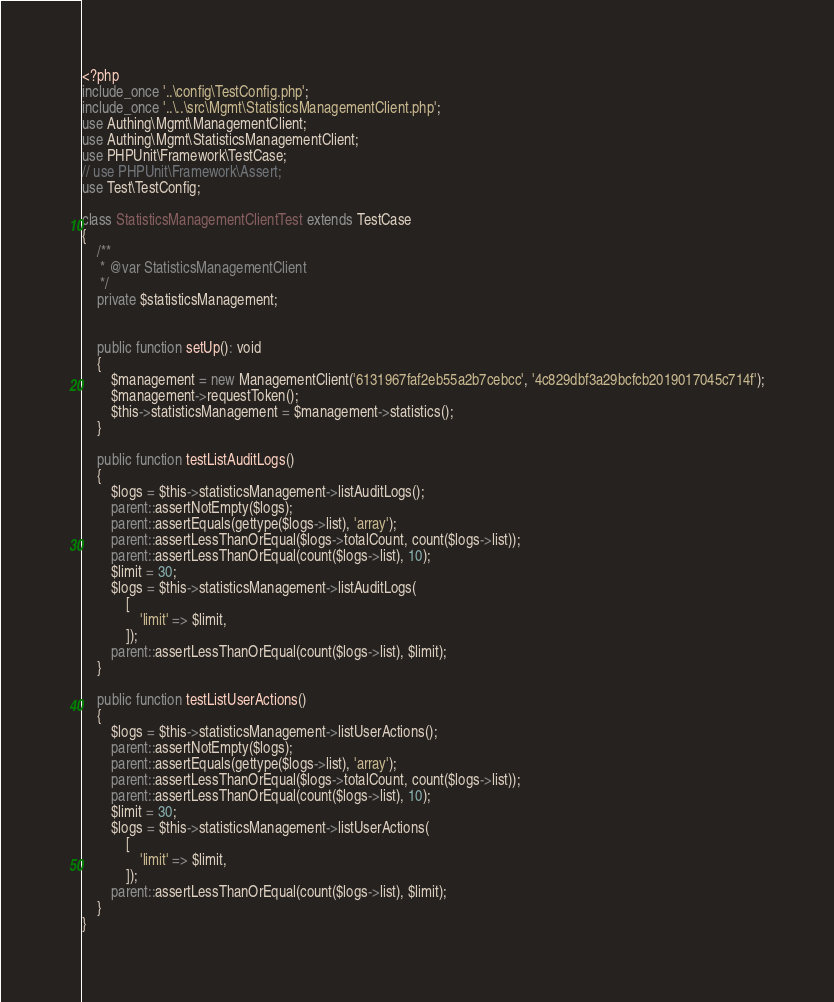Convert code to text. <code><loc_0><loc_0><loc_500><loc_500><_PHP_><?php
include_once '..\config\TestConfig.php';
include_once '..\..\src\Mgmt\StatisticsManagementClient.php';
use Authing\Mgmt\ManagementClient;
use Authing\Mgmt\StatisticsManagementClient;
use PHPUnit\Framework\TestCase;
// use PHPUnit\Framework\Assert;
use Test\TestConfig;

class StatisticsManagementClientTest extends TestCase
{
    /**
     * @var StatisticsManagementClient
     */
    private $statisticsManagement;


    public function setUp(): void
    {
        $management = new ManagementClient('6131967faf2eb55a2b7cebcc', '4c829dbf3a29bcfcb2019017045c714f');
        $management->requestToken();
        $this->statisticsManagement = $management->statistics();
    }

    public function testListAuditLogs()
    {
        $logs = $this->statisticsManagement->listAuditLogs();
        parent::assertNotEmpty($logs);
        parent::assertEquals(gettype($logs->list), 'array');
        parent::assertLessThanOrEqual($logs->totalCount, count($logs->list));
        parent::assertLessThanOrEqual(count($logs->list), 10);
        $limit = 30;
        $logs = $this->statisticsManagement->listAuditLogs(
            [
                'limit' => $limit,
            ]);
        parent::assertLessThanOrEqual(count($logs->list), $limit);
    }

    public function testListUserActions()
    {
        $logs = $this->statisticsManagement->listUserActions();
        parent::assertNotEmpty($logs);
        parent::assertEquals(gettype($logs->list), 'array');
        parent::assertLessThanOrEqual($logs->totalCount, count($logs->list));
        parent::assertLessThanOrEqual(count($logs->list), 10);
        $limit = 30;
        $logs = $this->statisticsManagement->listUserActions(
            [
                'limit' => $limit,
            ]);
        parent::assertLessThanOrEqual(count($logs->list), $limit);
    }
}
</code> 